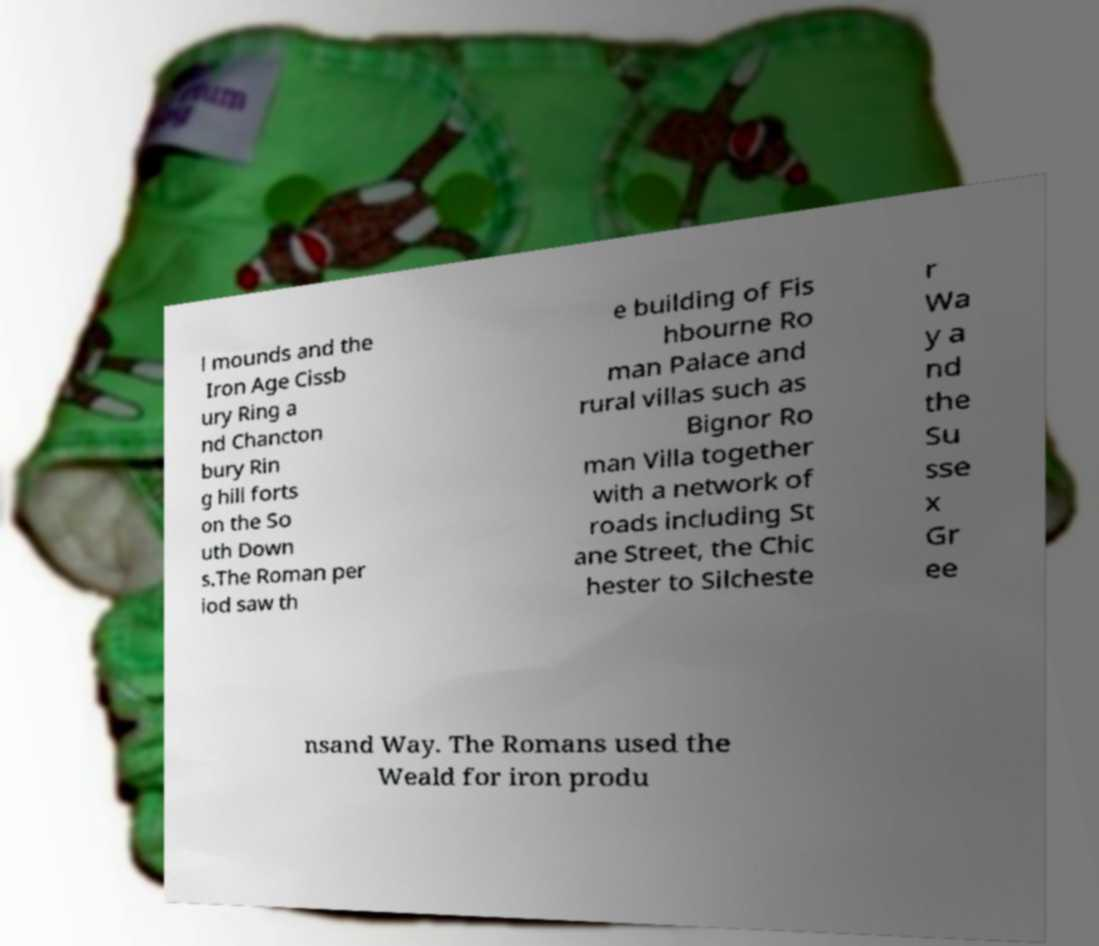For documentation purposes, I need the text within this image transcribed. Could you provide that? l mounds and the Iron Age Cissb ury Ring a nd Chancton bury Rin g hill forts on the So uth Down s.The Roman per iod saw th e building of Fis hbourne Ro man Palace and rural villas such as Bignor Ro man Villa together with a network of roads including St ane Street, the Chic hester to Silcheste r Wa y a nd the Su sse x Gr ee nsand Way. The Romans used the Weald for iron produ 